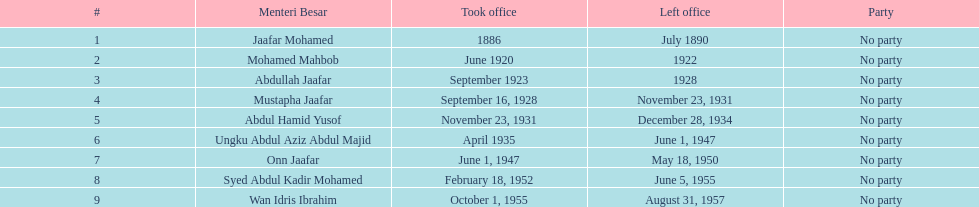Over how many years did jaafar mohamed serve in office? 4. 